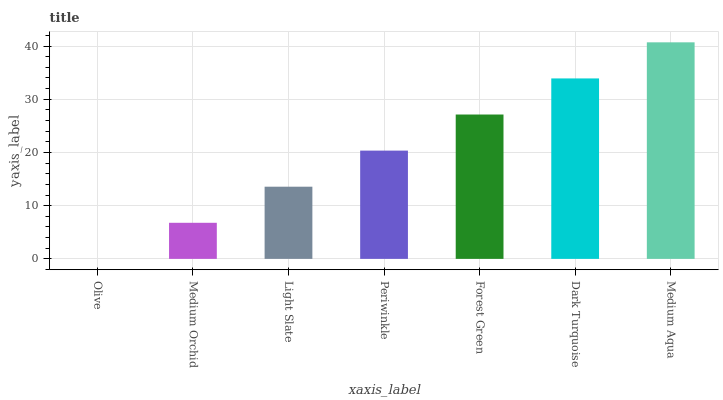Is Olive the minimum?
Answer yes or no. Yes. Is Medium Aqua the maximum?
Answer yes or no. Yes. Is Medium Orchid the minimum?
Answer yes or no. No. Is Medium Orchid the maximum?
Answer yes or no. No. Is Medium Orchid greater than Olive?
Answer yes or no. Yes. Is Olive less than Medium Orchid?
Answer yes or no. Yes. Is Olive greater than Medium Orchid?
Answer yes or no. No. Is Medium Orchid less than Olive?
Answer yes or no. No. Is Periwinkle the high median?
Answer yes or no. Yes. Is Periwinkle the low median?
Answer yes or no. Yes. Is Medium Aqua the high median?
Answer yes or no. No. Is Medium Aqua the low median?
Answer yes or no. No. 